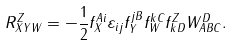<formula> <loc_0><loc_0><loc_500><loc_500>R _ { X Y W } ^ { Z } = - \frac { 1 } { 2 } f _ { X } ^ { A i } \varepsilon _ { i j } f _ { Y } ^ { j B } f _ { W } ^ { k C } f _ { k D } ^ { Z } W _ { A B C } ^ { D } .</formula> 